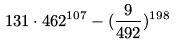Convert formula to latex. <formula><loc_0><loc_0><loc_500><loc_500>1 3 1 \cdot 4 6 2 ^ { 1 0 7 } - ( \frac { 9 } { 4 9 2 } ) ^ { 1 9 8 }</formula> 